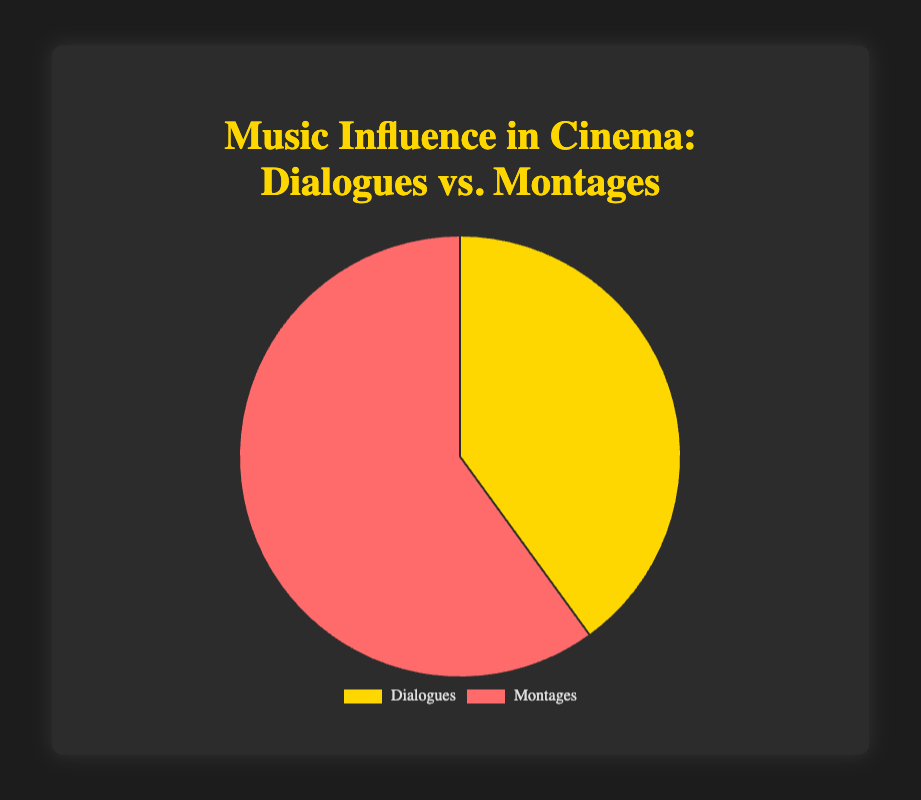What are the total values for Dialogues and Montages? According to the pie chart, the value for Dialogues is given as 100 and for Montages as 150. Adding them together, we get a total of 100 + 150 = 250.
Answer: 250 Which category has the higher value, Dialogues or Montages? From the pie chart, Montages have a value of 150 while Dialogues have a value of 100. Since 150 is greater than 100, Montages have the higher value.
Answer: Montages What is the difference between the values of Montages and Dialogues? The value for Montages is 150 and the value for Dialogues is 100. The difference is calculated as 150 - 100 = 50.
Answer: 50 What percentage of the total does the Dialogues category represent? The total value is 250, with Dialogues representing 100 of that. To find the percentage, we calculate (100/250) * 100, which equals 40%.
Answer: 40% If the total value was to increase by 50, making it 300, what would be the new percentage for Montages? The original total is 250, and Montages represent 150 of that. If the total increases to 300, the percentage for Montages is (150/300) * 100 = 50%.
Answer: 50% Which segment has the golden-yellow color in the pie chart? From the visual attributes described, the golden-yellow color represents the Dialogues category.
Answer: Dialogues If the values were scaled such that Montages doubled, what would be the new value of Montages? The original value of Montages is 150. If it doubled, the new value would be 150 * 2 = 300.
Answer: 300 How does the color scheme differentiate between Dialogues and Montages? The pie chart uses golden-yellow for Dialogues and red for Montages to visually differentiate the categories.
Answer: Golden-yellow for Dialogues, red for Montages What is the ratio of the Montages value to the Dialogues value? The value for Montages is 150 and for Dialogues is 100. The ratio is therefore 150:100, which simplifies to 3:2.
Answer: 3:2 If you were to remove one category, making the chart a single category, what percentage of the chart would the remaining category occupy? If one category is removed, the remaining category would occupy 100% of the chart since it would be the only one present.
Answer: 100% 